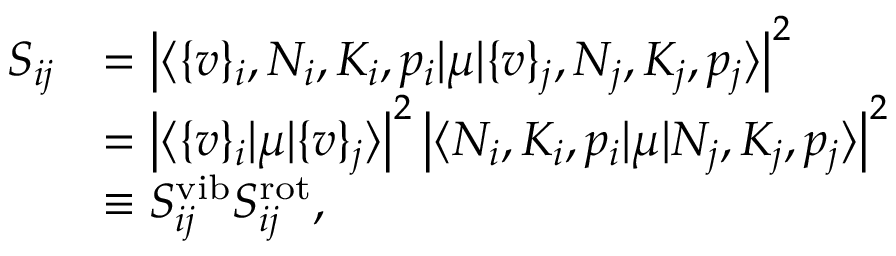<formula> <loc_0><loc_0><loc_500><loc_500>\begin{array} { r l } { S _ { i j } } & { = \left | \langle \{ v \} _ { i } , N _ { i } , K _ { i } , p _ { i } | \mu | \{ v \} _ { j } , N _ { j } , K _ { j } , p _ { j } \rangle \right | ^ { 2 } } \\ & { = \left | \langle \{ v \} _ { i } | \mu | \{ v \} _ { j } \rangle \right | ^ { 2 } \left | \langle N _ { i } , K _ { i } , p _ { i } | \mu | N _ { j } , K _ { j } , p _ { j } \rangle \right | ^ { 2 } } \\ & { \equiv S _ { i j } ^ { v i b } S _ { i j } ^ { r o t } , } \end{array}</formula> 